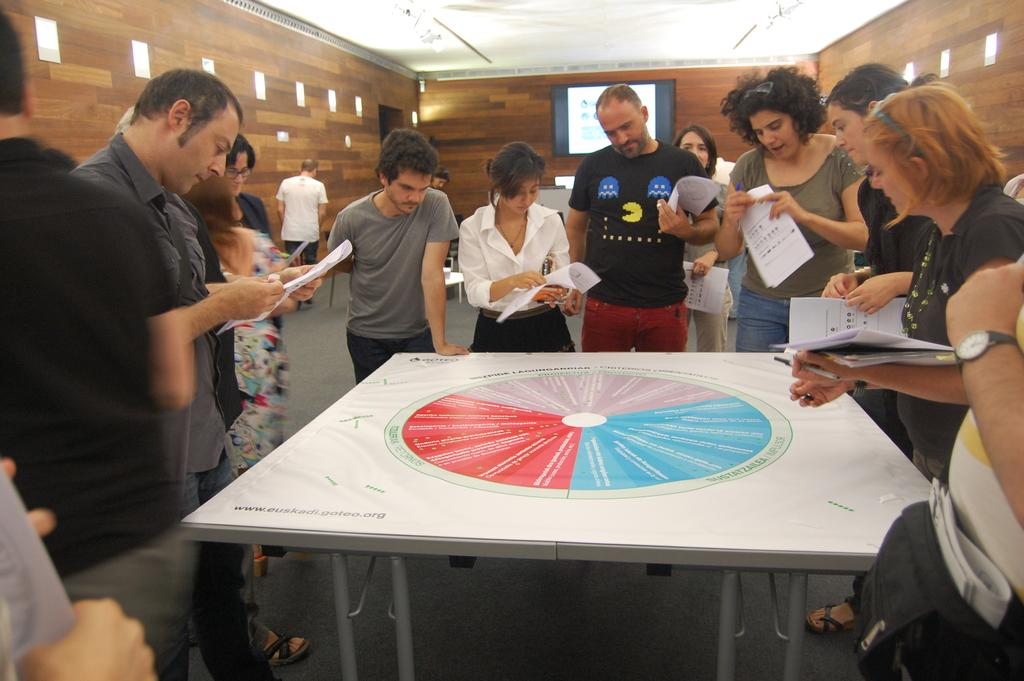How many people are present in the image? There is a group of people in the image. What are some of the people holding in their hands? Some people are holding papers in their hands. What is on the table in the image? There is a paper on the table. What are the people in the image doing? The people are watching the paper on the table. Can you see any flies buzzing around the people in the image? There is no mention of flies in the provided facts, so we cannot determine if any are present in the image. 